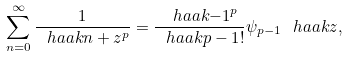<formula> <loc_0><loc_0><loc_500><loc_500>\sum _ { n = 0 } ^ { \infty } \frac { 1 } { \ h a a k { n + z } ^ { p } } = \frac { \ h a a k { - 1 } ^ { p } } { \ h a a k { p - 1 } ! } \psi _ { p - 1 } \ h a a k { z } ,</formula> 